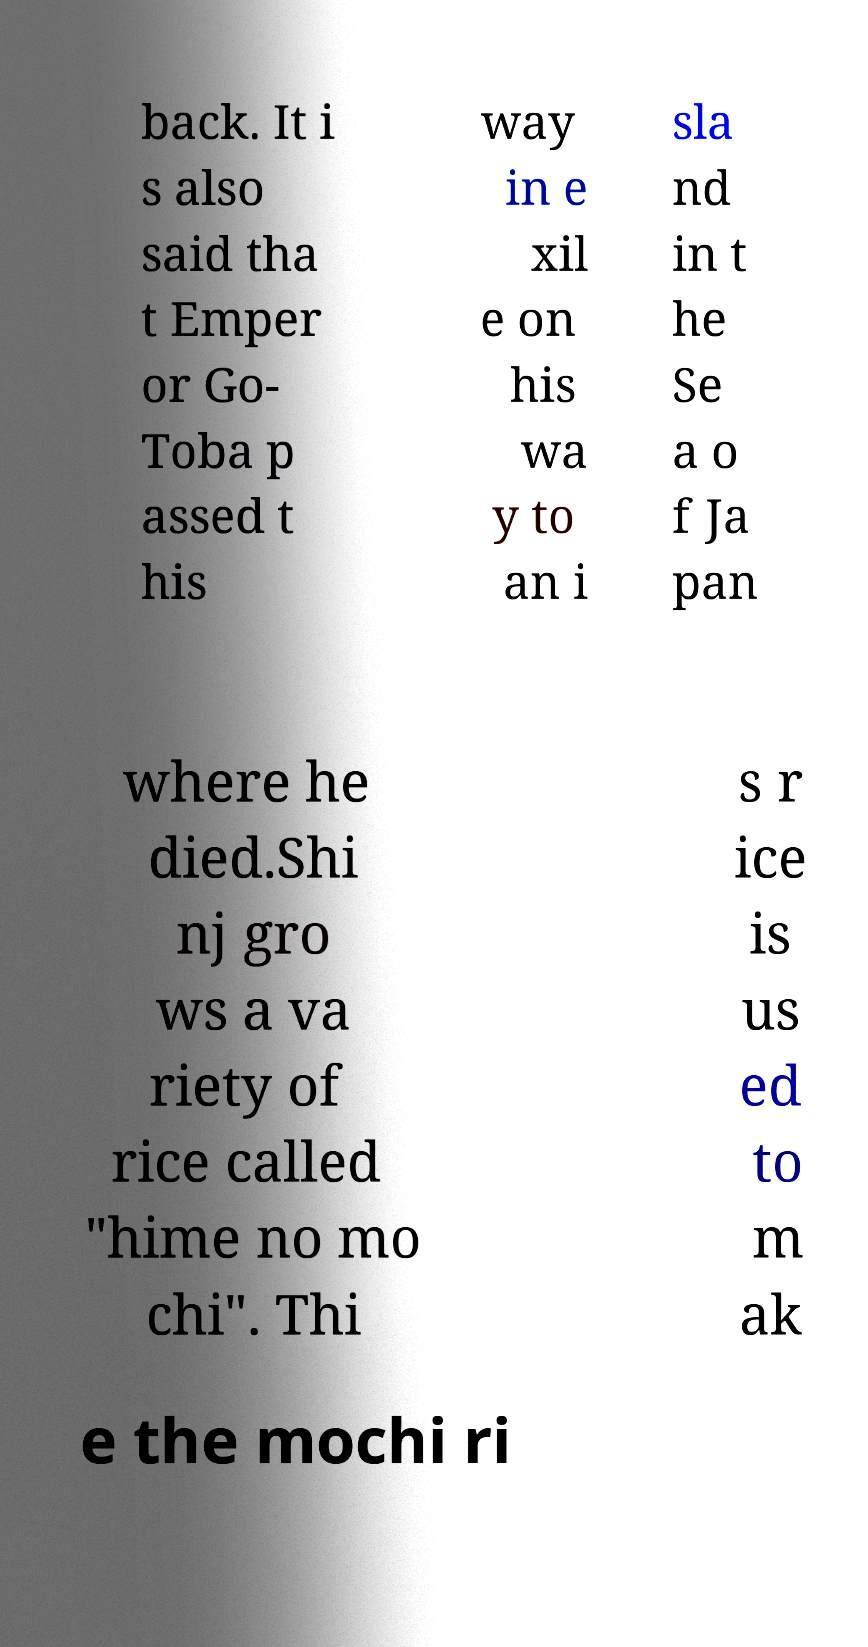What messages or text are displayed in this image? I need them in a readable, typed format. back. It i s also said tha t Emper or Go- Toba p assed t his way in e xil e on his wa y to an i sla nd in t he Se a o f Ja pan where he died.Shi nj gro ws a va riety of rice called "hime no mo chi". Thi s r ice is us ed to m ak e the mochi ri 